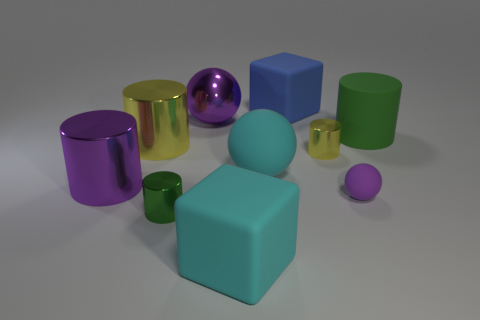Is the color of the block in front of the big yellow cylinder the same as the metallic sphere? No, the color of the block in front of the big yellow cylinder, which is a muted blue, is not the same as the metallic sphere. The sphere has a reflective purple surface, showing a notable difference in hue and material properties. 